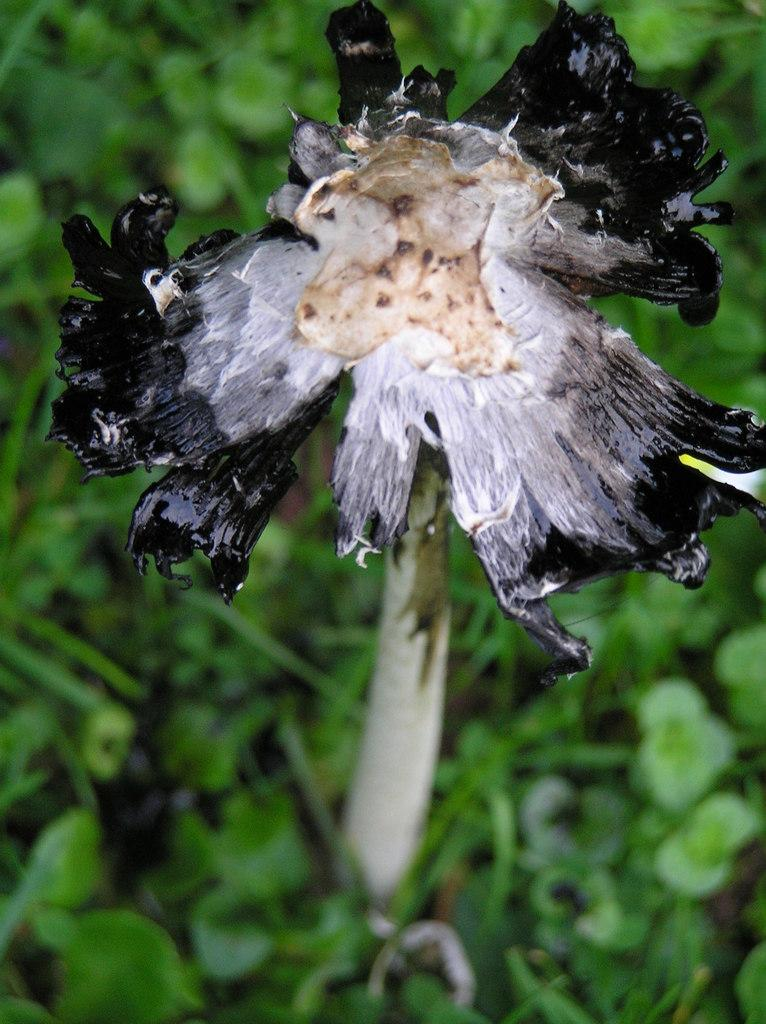What type of living organism can be seen in the image? There is a flower in the image. Are there any other plants visible in the image? Yes, there are plants in the image. What type of stamp can be seen on the flower in the image? There is no stamp present on the flower in the image. How many ducks are visible in the image? There are no ducks present in the image. 